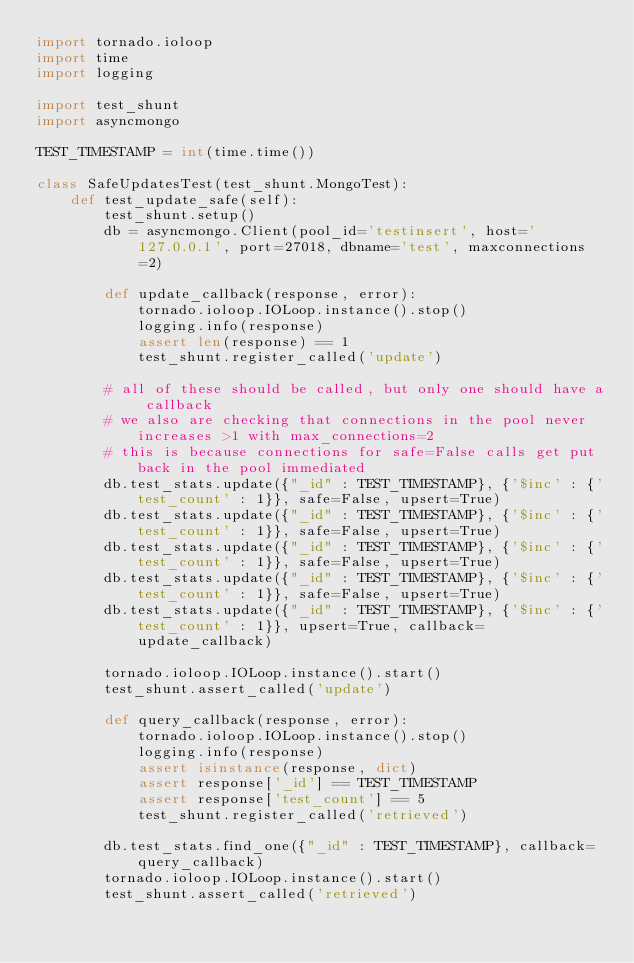Convert code to text. <code><loc_0><loc_0><loc_500><loc_500><_Python_>import tornado.ioloop
import time
import logging

import test_shunt
import asyncmongo

TEST_TIMESTAMP = int(time.time())

class SafeUpdatesTest(test_shunt.MongoTest):
    def test_update_safe(self):
        test_shunt.setup()
        db = asyncmongo.Client(pool_id='testinsert', host='127.0.0.1', port=27018, dbname='test', maxconnections=2)
        
        def update_callback(response, error):
            tornado.ioloop.IOLoop.instance().stop()
            logging.info(response)
            assert len(response) == 1
            test_shunt.register_called('update')

        # all of these should be called, but only one should have a callback
        # we also are checking that connections in the pool never increases >1 with max_connections=2
        # this is because connections for safe=False calls get put back in the pool immediated
        db.test_stats.update({"_id" : TEST_TIMESTAMP}, {'$inc' : {'test_count' : 1}}, safe=False, upsert=True)
        db.test_stats.update({"_id" : TEST_TIMESTAMP}, {'$inc' : {'test_count' : 1}}, safe=False, upsert=True)
        db.test_stats.update({"_id" : TEST_TIMESTAMP}, {'$inc' : {'test_count' : 1}}, safe=False, upsert=True)
        db.test_stats.update({"_id" : TEST_TIMESTAMP}, {'$inc' : {'test_count' : 1}}, safe=False, upsert=True)
        db.test_stats.update({"_id" : TEST_TIMESTAMP}, {'$inc' : {'test_count' : 1}}, upsert=True, callback=update_callback)
        
        tornado.ioloop.IOLoop.instance().start()
        test_shunt.assert_called('update')
        
        def query_callback(response, error):
            tornado.ioloop.IOLoop.instance().stop()
            logging.info(response)
            assert isinstance(response, dict)
            assert response['_id'] == TEST_TIMESTAMP
            assert response['test_count'] == 5
            test_shunt.register_called('retrieved')

        db.test_stats.find_one({"_id" : TEST_TIMESTAMP}, callback=query_callback)
        tornado.ioloop.IOLoop.instance().start()
        test_shunt.assert_called('retrieved')
</code> 